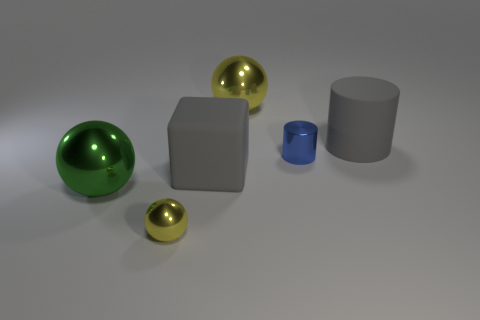Is the cube the same color as the rubber cylinder?
Your answer should be very brief. Yes. What number of objects are large objects that are on the left side of the gray cylinder or metallic cylinders that are in front of the gray cylinder?
Provide a short and direct response. 4. What color is the big metal sphere that is to the left of the yellow metallic thing in front of the rubber cylinder?
Give a very brief answer. Green. The other tiny object that is the same material as the small blue object is what color?
Provide a short and direct response. Yellow. What number of metal objects have the same color as the tiny sphere?
Make the answer very short. 1. How many things are tiny gray cubes or gray cubes?
Your answer should be compact. 1. There is a gray thing that is the same size as the cube; what is its shape?
Offer a terse response. Cylinder. How many big objects are in front of the matte cube and behind the blue metal thing?
Your response must be concise. 0. There is a yellow object that is behind the large gray cube; what is its material?
Keep it short and to the point. Metal. What size is the thing that is the same material as the big cylinder?
Give a very brief answer. Large. 